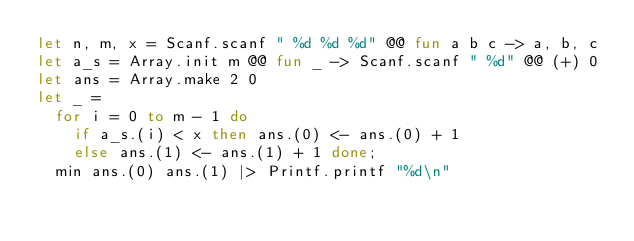<code> <loc_0><loc_0><loc_500><loc_500><_OCaml_>let n, m, x = Scanf.scanf " %d %d %d" @@ fun a b c -> a, b, c
let a_s = Array.init m @@ fun _ -> Scanf.scanf " %d" @@ (+) 0
let ans = Array.make 2 0
let _ =
  for i = 0 to m - 1 do
    if a_s.(i) < x then ans.(0) <- ans.(0) + 1
    else ans.(1) <- ans.(1) + 1 done;
  min ans.(0) ans.(1) |> Printf.printf "%d\n"</code> 